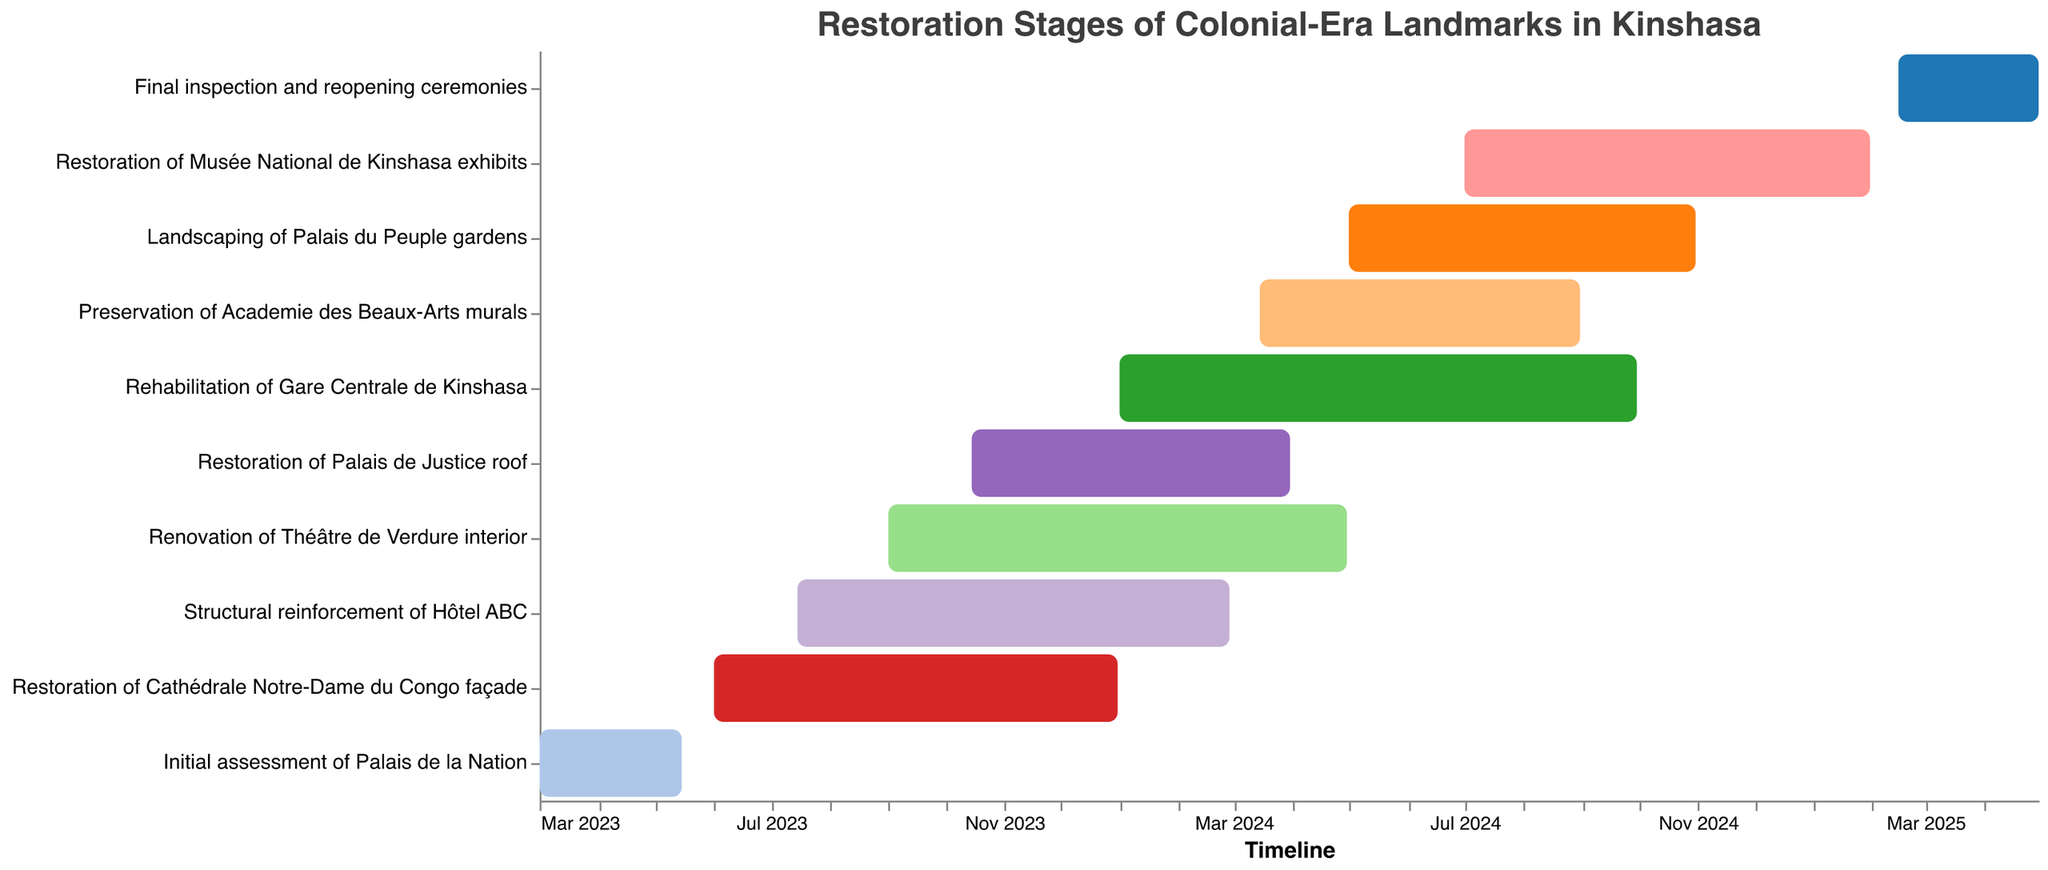What's the first task in the restoration timeline? Look at the timeline on the x-axis and find the earliest start date. The "Initial assessment of Palais de la Nation" starts on March 1, 2023.
Answer: Initial assessment of Palais de la Nation When does the restoration of the Cathédrale Notre-Dame du Congo façade end? On the y-axis, locate the task "Restoration of Cathédrale Notre-Dame du Congo façade," then move across to its end date on the timeline. It ends on December 31, 2023.
Answer: December 31, 2023 Which task takes the longest time to complete? Measure the duration of each task by calculating the difference between start and end dates. The "Rehabilitation of Gare Centrale de Kinshasa" takes the longest, from January 1, 2024, to September 30, 2024, lasting 9 months.
Answer: Rehabilitation of Gare Centrale de Kinshasa How many tasks are there in total? Count the number of distinct tasks listed on the y-axis.
Answer: 10 Which tasks are being worked on during September 2024? Identify tasks with September 2024 within their start and end dates. These are "Rehabilitation of Gare Centrale de Kinshasa," "Landscaping of Palais du Peuple gardens," and "Restoration of Musée National de Kinshasa exhibits."
Answer: Rehabilitation of Gare Centrale de Kinshasa, Landscaping of Palais du Peuple gardens, Restoration of Musée National de Kinshasa exhibits What is the last task to be completed? Find the task with the latest end date on the timeline. The "Final inspection and reopening ceremonies" ends on April 30, 2025.
Answer: Final inspection and reopening ceremonies Which restoration task overlaps with the "Renovation of Théâtre de Verdure interior"? "Renovation of Théâtre de Verdure interior" runs from September 1, 2023, to April 30, 2024. Overlapping tasks are "Restoration of Palais de Justice roof," "Rehabilitation of Gare Centrale de Kinshasa," and "Preservation of Academie des Beaux-Arts murals."
Answer: Restoration of Palais de Justice roof, Rehabilitation of Gare Centrale de Kinshasa, Preservation of Academie des Beaux-Arts murals What is the average duration of a task? Calculate the duration of each task and find the average. Durations in days are 75, 214, 228, 243, 169, 273, 170, 184, 214, and 75 respectively. The sum is 1845 days. Divided by 10, the average duration is 184.5 days.
Answer: 184.5 days In how many months does the "Restoration of Musée National de Kinshasa exhibits" take place? Calculate the duration from July 1, 2024, to January 31, 2025. This covers parts of 7 months.
Answer: 7 months When do the tasks "Final inspection and reopening ceremonies" begin? Locate "Final inspection and reopening ceremonies" on the y-axis and move to its start date on the x-axis. It begins on February 15, 2025.
Answer: February 15, 2025 